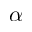<formula> <loc_0><loc_0><loc_500><loc_500>\alpha</formula> 